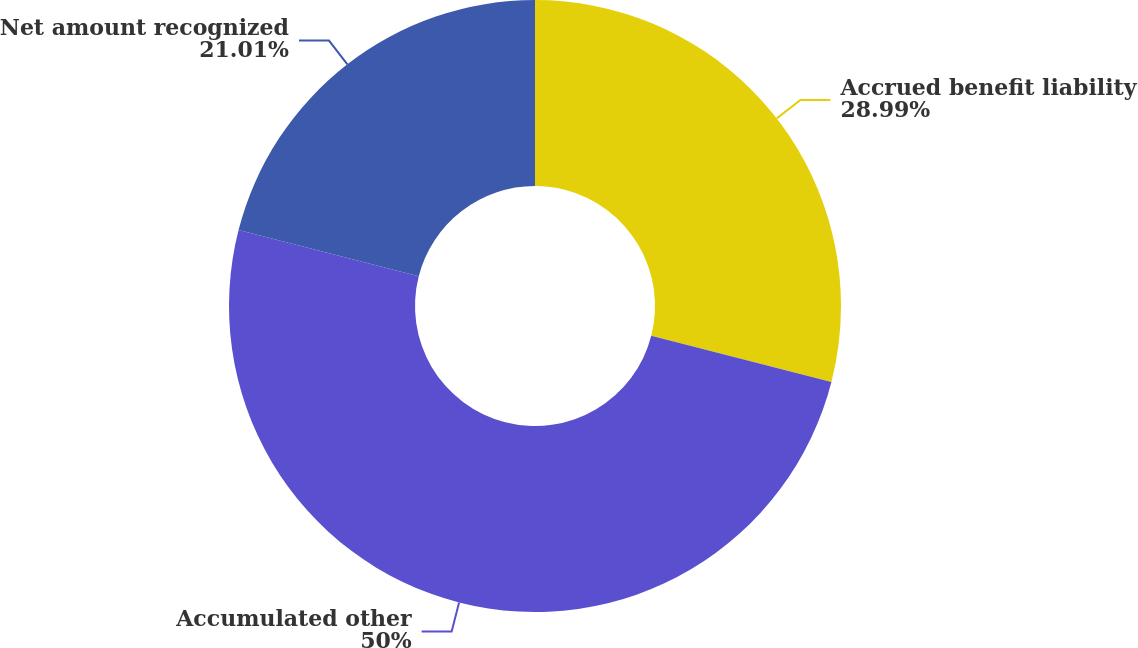Convert chart to OTSL. <chart><loc_0><loc_0><loc_500><loc_500><pie_chart><fcel>Accrued benefit liability<fcel>Accumulated other<fcel>Net amount recognized<nl><fcel>28.99%<fcel>50.0%<fcel>21.01%<nl></chart> 